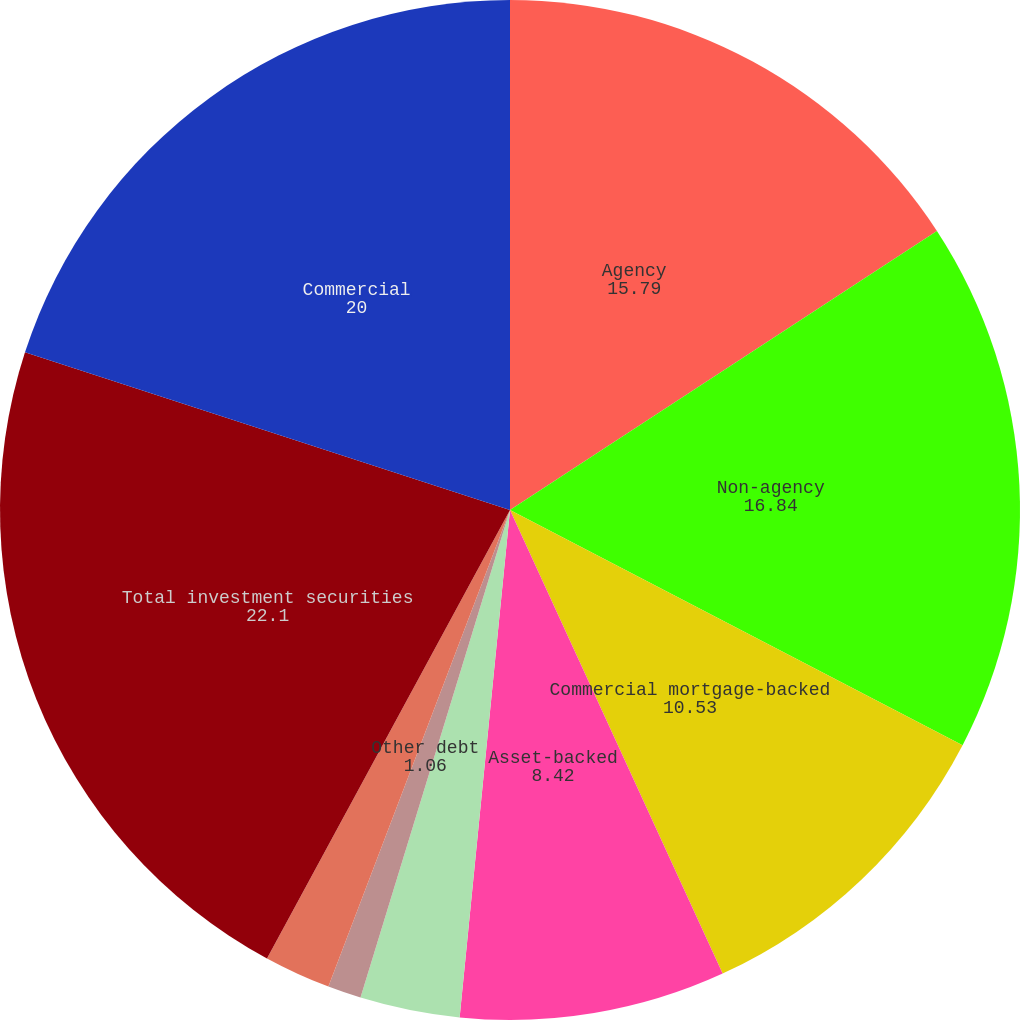Convert chart. <chart><loc_0><loc_0><loc_500><loc_500><pie_chart><fcel>Agency<fcel>Non-agency<fcel>Commercial mortgage-backed<fcel>Asset-backed<fcel>US Treasury and government<fcel>State and municipal<fcel>Other debt<fcel>Corporate stocks and other<fcel>Total investment securities<fcel>Commercial<nl><fcel>15.79%<fcel>16.84%<fcel>10.53%<fcel>8.42%<fcel>0.0%<fcel>3.16%<fcel>1.06%<fcel>2.11%<fcel>22.1%<fcel>20.0%<nl></chart> 